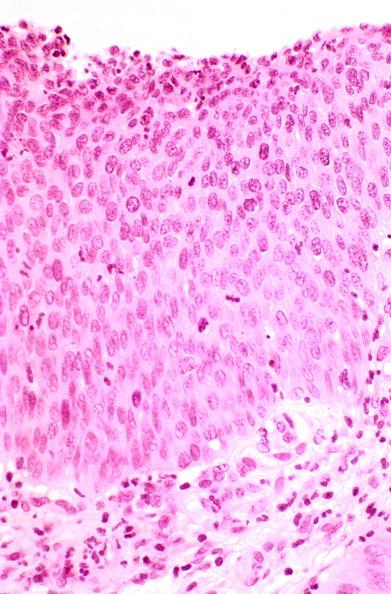where is this from?
Answer the question using a single word or phrase. Female reproductive system 